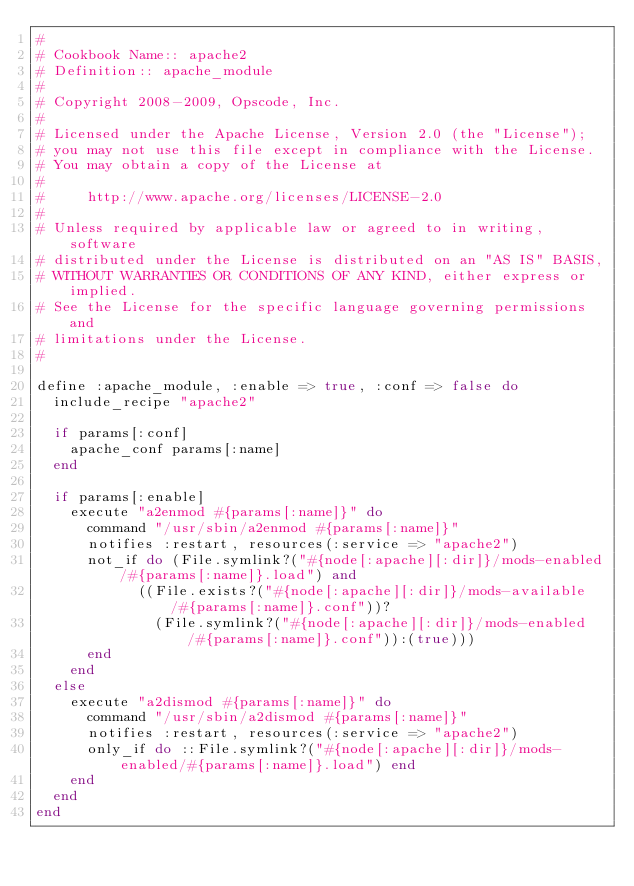<code> <loc_0><loc_0><loc_500><loc_500><_Ruby_>#
# Cookbook Name:: apache2
# Definition:: apache_module
#
# Copyright 2008-2009, Opscode, Inc.
#
# Licensed under the Apache License, Version 2.0 (the "License");
# you may not use this file except in compliance with the License.
# You may obtain a copy of the License at
#
#     http://www.apache.org/licenses/LICENSE-2.0
#
# Unless required by applicable law or agreed to in writing, software
# distributed under the License is distributed on an "AS IS" BASIS,
# WITHOUT WARRANTIES OR CONDITIONS OF ANY KIND, either express or implied.
# See the License for the specific language governing permissions and
# limitations under the License.
#

define :apache_module, :enable => true, :conf => false do
  include_recipe "apache2"
 
  if params[:conf]
    apache_conf params[:name]
  end
 
  if params[:enable]
    execute "a2enmod #{params[:name]}" do
      command "/usr/sbin/a2enmod #{params[:name]}"
      notifies :restart, resources(:service => "apache2")
      not_if do (File.symlink?("#{node[:apache][:dir]}/mods-enabled/#{params[:name]}.load") and
            ((File.exists?("#{node[:apache][:dir]}/mods-available/#{params[:name]}.conf"))?
              (File.symlink?("#{node[:apache][:dir]}/mods-enabled/#{params[:name]}.conf")):(true)))
      end
    end    
  else
    execute "a2dismod #{params[:name]}" do
      command "/usr/sbin/a2dismod #{params[:name]}"
      notifies :restart, resources(:service => "apache2")
      only_if do ::File.symlink?("#{node[:apache][:dir]}/mods-enabled/#{params[:name]}.load") end
    end
  end
end
</code> 